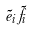<formula> <loc_0><loc_0><loc_500><loc_500>\tilde { e } _ { i } \tilde { f } _ { i }</formula> 